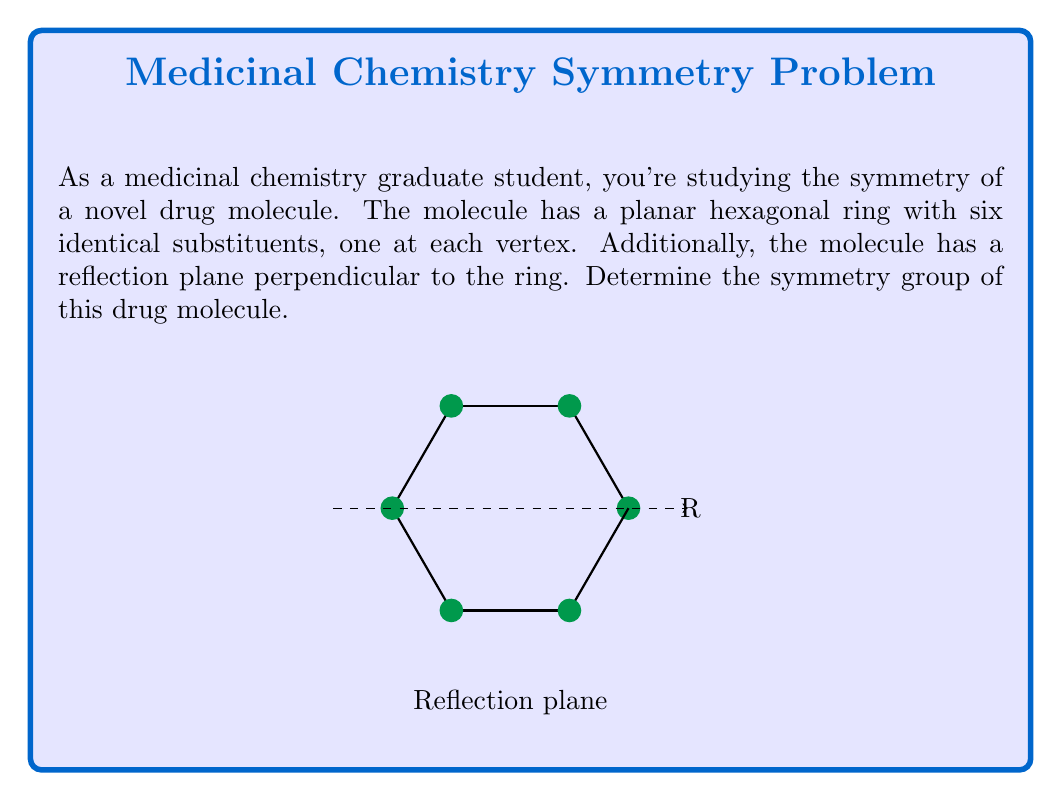Solve this math problem. To determine the symmetry group of this drug molecule, we need to identify all symmetry operations that leave the molecule unchanged:

1. Rotations:
   - The molecule has 6-fold rotational symmetry (rotations by 60°, 120°, 180°, 240°, 300°, and 360°).
   - We denote these as $e, C_6, C_6^2, C_6^3, C_6^4, C_6^5$.

2. Reflections:
   - There is one horizontal reflection plane (σh) perpendicular to the ring.
   - There are 6 vertical reflection planes (σv) passing through opposite vertices.

3. Improper rotations:
   - There are 6 improper rotations (S6, S3, S2, S6^5, S6^4, S6^3).

The total number of symmetry operations is 24.

This symmetry group is isomorphic to the dihedral group $D_{6h}$, which is the direct product of $D_6$ (the dihedral group of order 12) and $C_2$ (the cyclic group of order 2).

The group can be generated by three elements:
1. $C_6$: 60° rotation
2. σv: vertical reflection
3. σh: horizontal reflection

The group structure can be expressed as:

$$D_{6h} = \langle C_6, \sigma_v, \sigma_h | C_6^6 = \sigma_v^2 = \sigma_h^2 = e, \sigma_v C_6 \sigma_v = C_6^{-1}, \sigma_h C_6 = C_6 \sigma_h, \sigma_h \sigma_v = \sigma_v \sigma_h \rangle$$

This group is of order 24 and is non-abelian.
Answer: $D_{6h}$ 